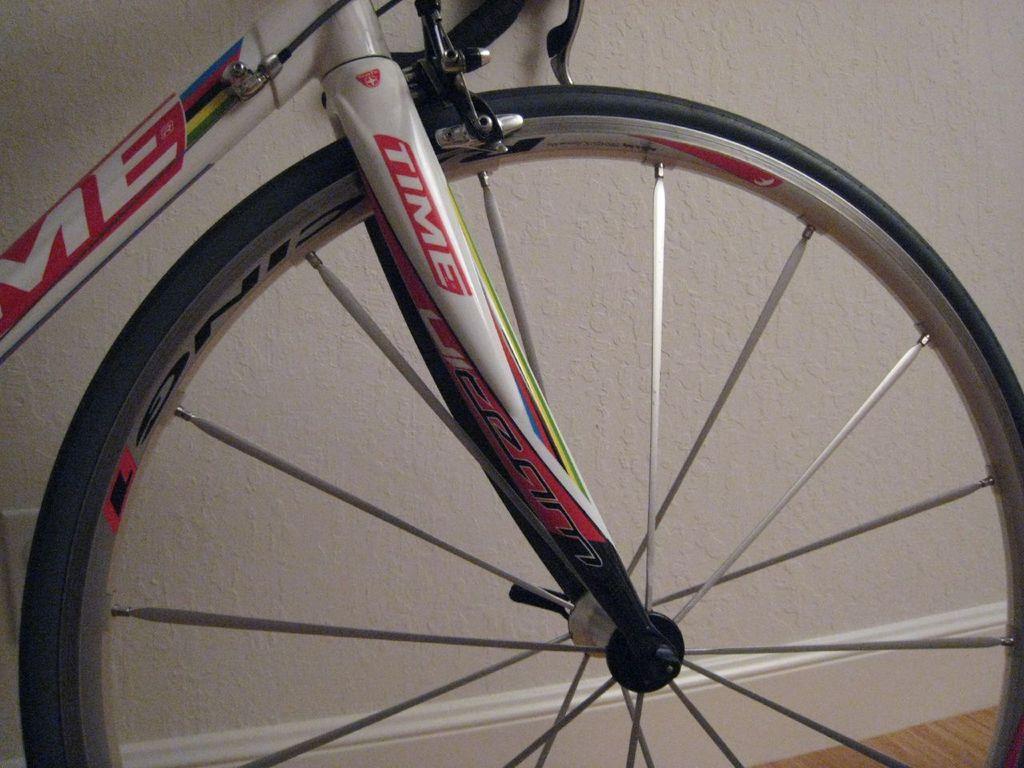Please provide a concise description of this image. In the foreground of this image, we see tire of a cycle and in the background, there is a wall and the surface. 